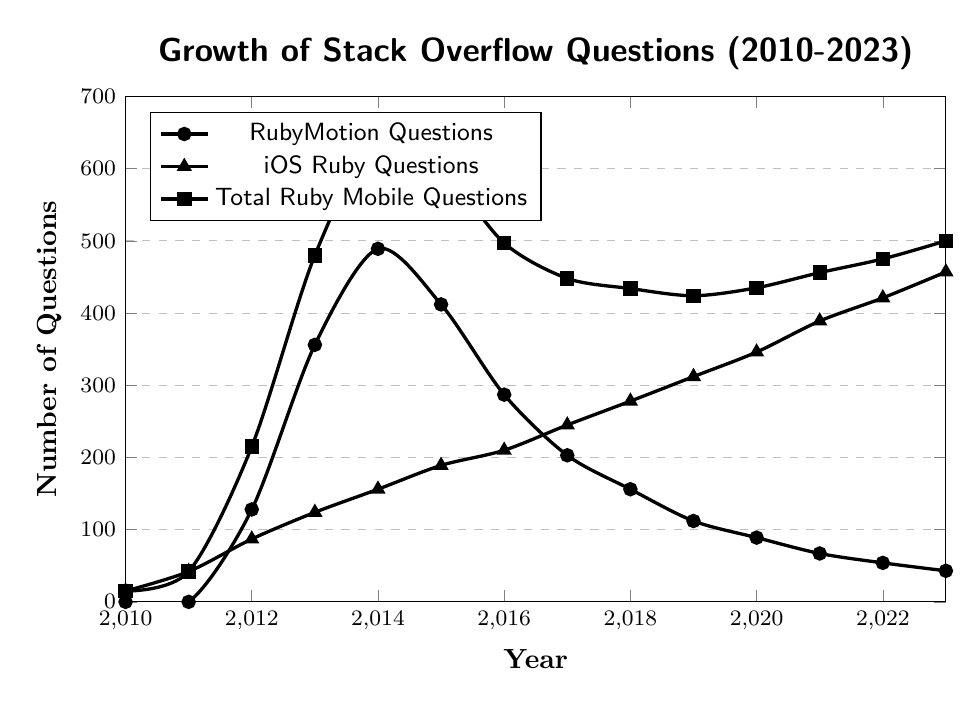What is the trend of RubyMotion questions from 2012 to 2023? From 2012 to 2014, RubyMotion questions increased sharply from 128 to 489. From 2015 onwards, the trend shows a decline, decreasing to 43 in 2023.
Answer: Decreasing Which category of questions had the highest number in 2023? In 2023, the iOS Ruby Questions had the highest number with 457 questions.
Answer: iOS Ruby Questions What is the difference between iOS Ruby Questions and RubyMotion Questions in 2016? In 2016, the number of iOS Ruby Questions was 210 and RubyMotion Questions was 287. The difference is 287 - 210 = 77.
Answer: 77 What is the total number of Ruby Mobile Questions in 2014 and 2023 combined? The Total Ruby Mobile Questions for 2014 is 645, and for 2023 is 500. The combined total is 645 + 500 = 1145.
Answer: 1145 Which year experienced the highest number of RubyMotion questions, and what was the number? The highest number of RubyMotion questions was in 2014, with 489 questions.
Answer: 2014, 489 How has the trend of Total Ruby Mobile Questions changed from 2010 to 2023? From 2010 to 2014, Total Ruby Mobile Questions increased consistently, peaking at 645 in 2014. After a decrease till 2017, they fluctuated but generally increased, reaching a peak of 500 in 2023.
Answer: Increasing with fluctuations By what percentage did the number of RubyMotion Questions decrease from 2014 to 2023? In 2014, there were 489 RubyMotion questions; in 2023, there were 43. The percentage decrease is ((489 - 43) / 489) * 100 ≈ 91.2%.
Answer: 91.2% What is the average number of iOS Ruby Questions from 2010 to 2023? Summing all iOS Ruby Questions from 2010 to 2023: 15 + 42 + 87 + 124 + 156 + 189 + 210 + 245 + 278 + 312 + 346 + 389 + 421 + 457 = 3271. Dividing by 14 (number of years): 3271 / 14 ≈ 233.6.
Answer: 233.6 Which category shows a steadily increasing trend from 2010 to 2023? The iOS Ruby Questions show a steadily increasing trend from 2010 to 2023, with the number consistently rising each year.
Answer: iOS Ruby Questions 